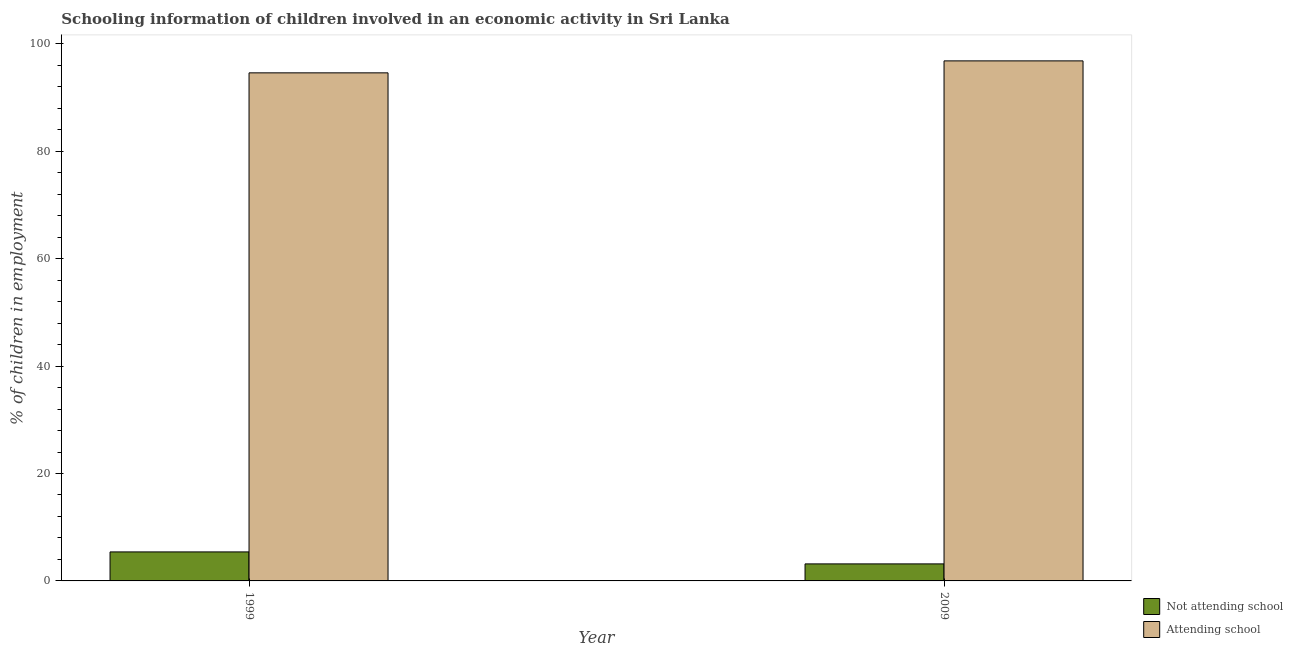Are the number of bars per tick equal to the number of legend labels?
Offer a terse response. Yes. How many bars are there on the 2nd tick from the left?
Give a very brief answer. 2. Across all years, what is the maximum percentage of employed children who are attending school?
Offer a very short reply. 96.83. Across all years, what is the minimum percentage of employed children who are attending school?
Your answer should be compact. 94.6. What is the total percentage of employed children who are attending school in the graph?
Ensure brevity in your answer.  191.43. What is the difference between the percentage of employed children who are not attending school in 1999 and that in 2009?
Your answer should be compact. 2.23. What is the difference between the percentage of employed children who are not attending school in 2009 and the percentage of employed children who are attending school in 1999?
Offer a terse response. -2.23. What is the average percentage of employed children who are attending school per year?
Offer a very short reply. 95.71. In how many years, is the percentage of employed children who are attending school greater than 40 %?
Provide a succinct answer. 2. What is the ratio of the percentage of employed children who are not attending school in 1999 to that in 2009?
Give a very brief answer. 1.7. What does the 1st bar from the left in 2009 represents?
Your answer should be very brief. Not attending school. What does the 1st bar from the right in 1999 represents?
Your answer should be very brief. Attending school. Are all the bars in the graph horizontal?
Ensure brevity in your answer.  No. How many years are there in the graph?
Your response must be concise. 2. What is the difference between two consecutive major ticks on the Y-axis?
Offer a terse response. 20. Does the graph contain any zero values?
Offer a terse response. No. Does the graph contain grids?
Ensure brevity in your answer.  No. How are the legend labels stacked?
Provide a short and direct response. Vertical. What is the title of the graph?
Your answer should be very brief. Schooling information of children involved in an economic activity in Sri Lanka. Does "Malaria" appear as one of the legend labels in the graph?
Give a very brief answer. No. What is the label or title of the Y-axis?
Provide a succinct answer. % of children in employment. What is the % of children in employment in Attending school in 1999?
Your answer should be compact. 94.6. What is the % of children in employment of Not attending school in 2009?
Offer a very short reply. 3.17. What is the % of children in employment of Attending school in 2009?
Provide a succinct answer. 96.83. Across all years, what is the maximum % of children in employment of Not attending school?
Make the answer very short. 5.4. Across all years, what is the maximum % of children in employment in Attending school?
Offer a terse response. 96.83. Across all years, what is the minimum % of children in employment of Not attending school?
Your answer should be compact. 3.17. Across all years, what is the minimum % of children in employment of Attending school?
Your response must be concise. 94.6. What is the total % of children in employment in Not attending school in the graph?
Offer a very short reply. 8.57. What is the total % of children in employment of Attending school in the graph?
Provide a succinct answer. 191.43. What is the difference between the % of children in employment of Not attending school in 1999 and that in 2009?
Provide a short and direct response. 2.23. What is the difference between the % of children in employment of Attending school in 1999 and that in 2009?
Your answer should be compact. -2.23. What is the difference between the % of children in employment in Not attending school in 1999 and the % of children in employment in Attending school in 2009?
Ensure brevity in your answer.  -91.43. What is the average % of children in employment of Not attending school per year?
Provide a succinct answer. 4.29. What is the average % of children in employment of Attending school per year?
Offer a terse response. 95.71. In the year 1999, what is the difference between the % of children in employment in Not attending school and % of children in employment in Attending school?
Offer a very short reply. -89.2. In the year 2009, what is the difference between the % of children in employment of Not attending school and % of children in employment of Attending school?
Your response must be concise. -93.66. What is the ratio of the % of children in employment of Not attending school in 1999 to that in 2009?
Keep it short and to the point. 1.7. What is the ratio of the % of children in employment of Attending school in 1999 to that in 2009?
Your response must be concise. 0.98. What is the difference between the highest and the second highest % of children in employment of Not attending school?
Provide a succinct answer. 2.23. What is the difference between the highest and the second highest % of children in employment of Attending school?
Provide a short and direct response. 2.23. What is the difference between the highest and the lowest % of children in employment in Not attending school?
Offer a terse response. 2.23. What is the difference between the highest and the lowest % of children in employment of Attending school?
Your response must be concise. 2.23. 